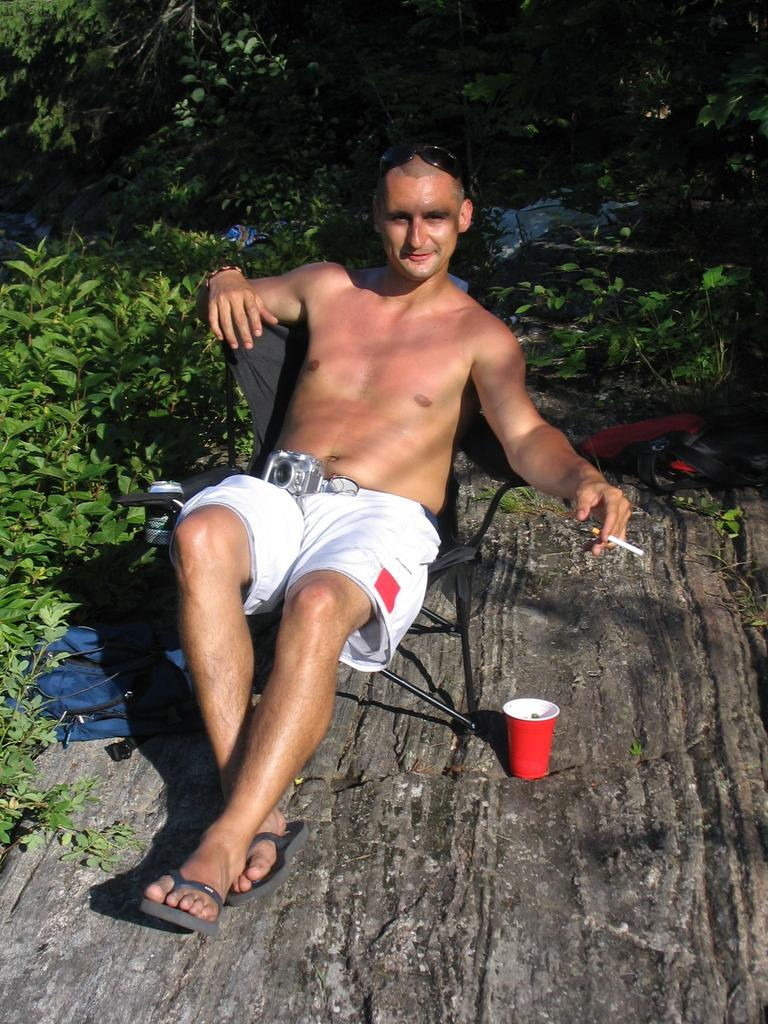What is the man in the image doing? The man is sitting on a chair in the image. What is the man holding in the image? The man is holding a cigar. What can be seen on the table in the image? There is a cup in the image. What is visible in the background of the image? There are plants in the background of the image. What object is used for capturing images in the image? There is a camera in the image. How many chairs are being attacked by the meat in the image? There is no meat or attack present in the image; it features a man sitting on a chair, holding a cigar, and surrounded by other objects. 